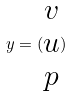<formula> <loc_0><loc_0><loc_500><loc_500>y = ( \begin{matrix} v \\ u \\ p \end{matrix} )</formula> 